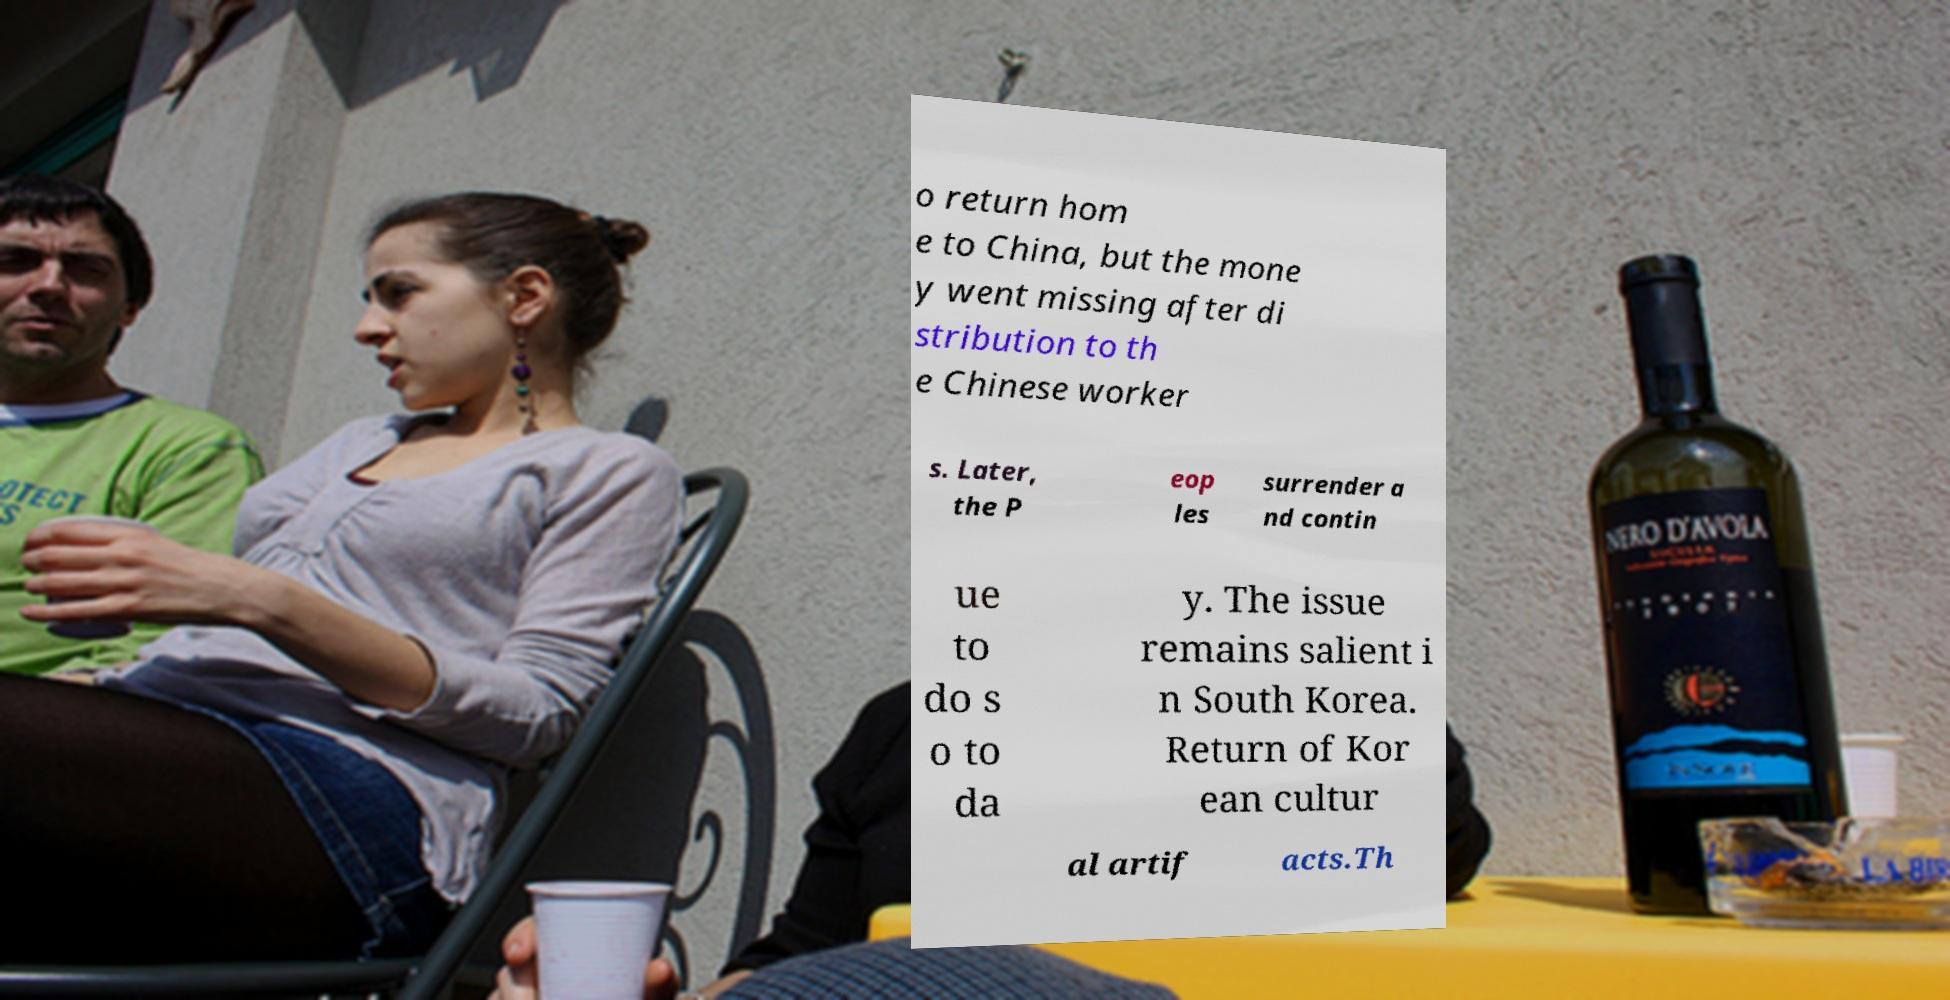There's text embedded in this image that I need extracted. Can you transcribe it verbatim? o return hom e to China, but the mone y went missing after di stribution to th e Chinese worker s. Later, the P eop les surrender a nd contin ue to do s o to da y. The issue remains salient i n South Korea. Return of Kor ean cultur al artif acts.Th 